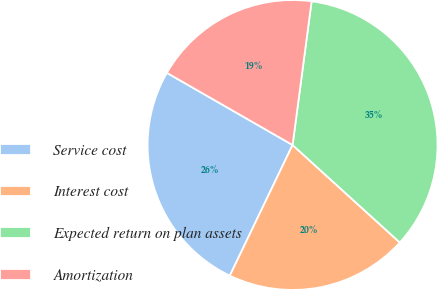Convert chart to OTSL. <chart><loc_0><loc_0><loc_500><loc_500><pie_chart><fcel>Service cost<fcel>Interest cost<fcel>Expected return on plan assets<fcel>Amortization<nl><fcel>26.17%<fcel>20.38%<fcel>34.65%<fcel>18.8%<nl></chart> 